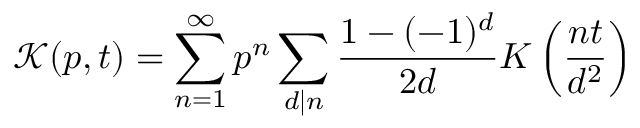Convert formula to latex. <formula><loc_0><loc_0><loc_500><loc_500>\mathcal { K } ( p , t ) = \sum _ { n = 1 } ^ { \infty } p ^ { n } \sum _ { d | n } \frac { 1 - ( - 1 ) ^ { d } } { 2 d } K \left ( \frac { n t } { d ^ { 2 } } \right )</formula> 